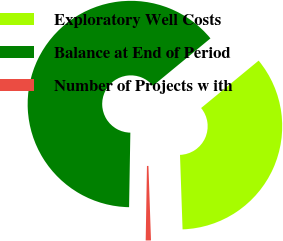<chart> <loc_0><loc_0><loc_500><loc_500><pie_chart><fcel>Exploratory Well Costs<fcel>Balance at End of Period<fcel>Number of Projects w ith<nl><fcel>35.42%<fcel>63.75%<fcel>0.82%<nl></chart> 